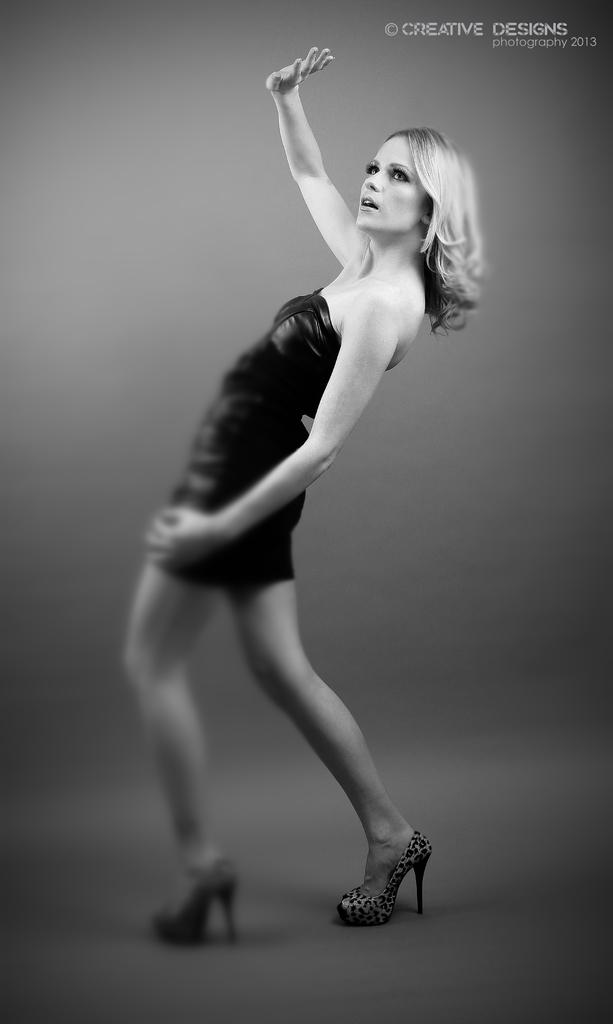Who is present in the image? There is a woman in the image. What is the woman doing in the image? The woman is standing on the floor. What is the color scheme of the image? The image is black and white. Where can text be found in the image? There is some text in the top right side of the image. What type of spark can be seen coming from the woman's hands in the image? There is no spark present in the image; it is a black and white image of a woman standing on the floor. 